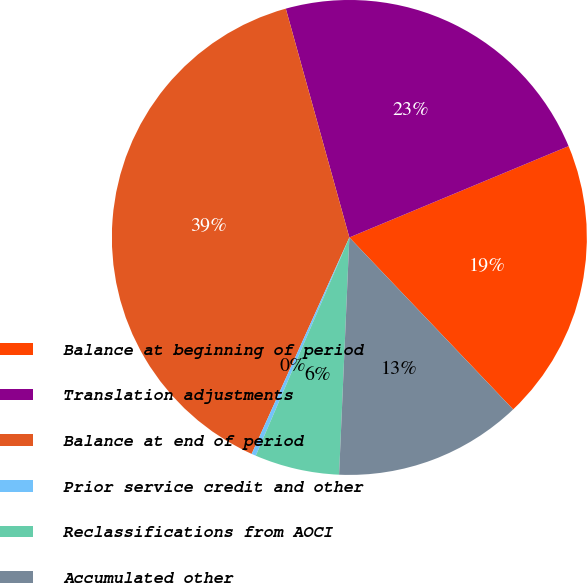<chart> <loc_0><loc_0><loc_500><loc_500><pie_chart><fcel>Balance at beginning of period<fcel>Translation adjustments<fcel>Balance at end of period<fcel>Prior service credit and other<fcel>Reclassifications from AOCI<fcel>Accumulated other<nl><fcel>19.17%<fcel>23.03%<fcel>38.94%<fcel>0.3%<fcel>5.76%<fcel>12.8%<nl></chart> 